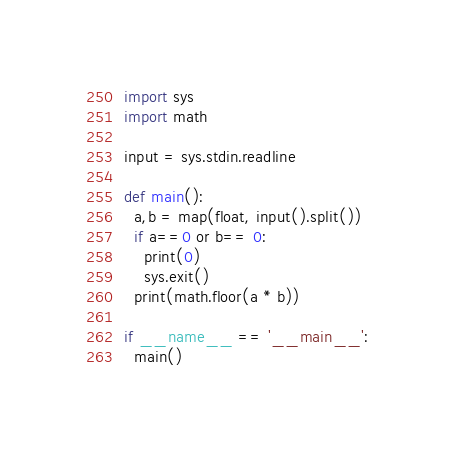Convert code to text. <code><loc_0><loc_0><loc_500><loc_500><_Python_>import sys
import math

input = sys.stdin.readline
 
def main():
  a,b = map(float, input().split())
  if a==0 or b== 0:
    print(0)
    sys.exit()
  print(math.floor(a * b))

if __name__ == '__main__':
  main()</code> 